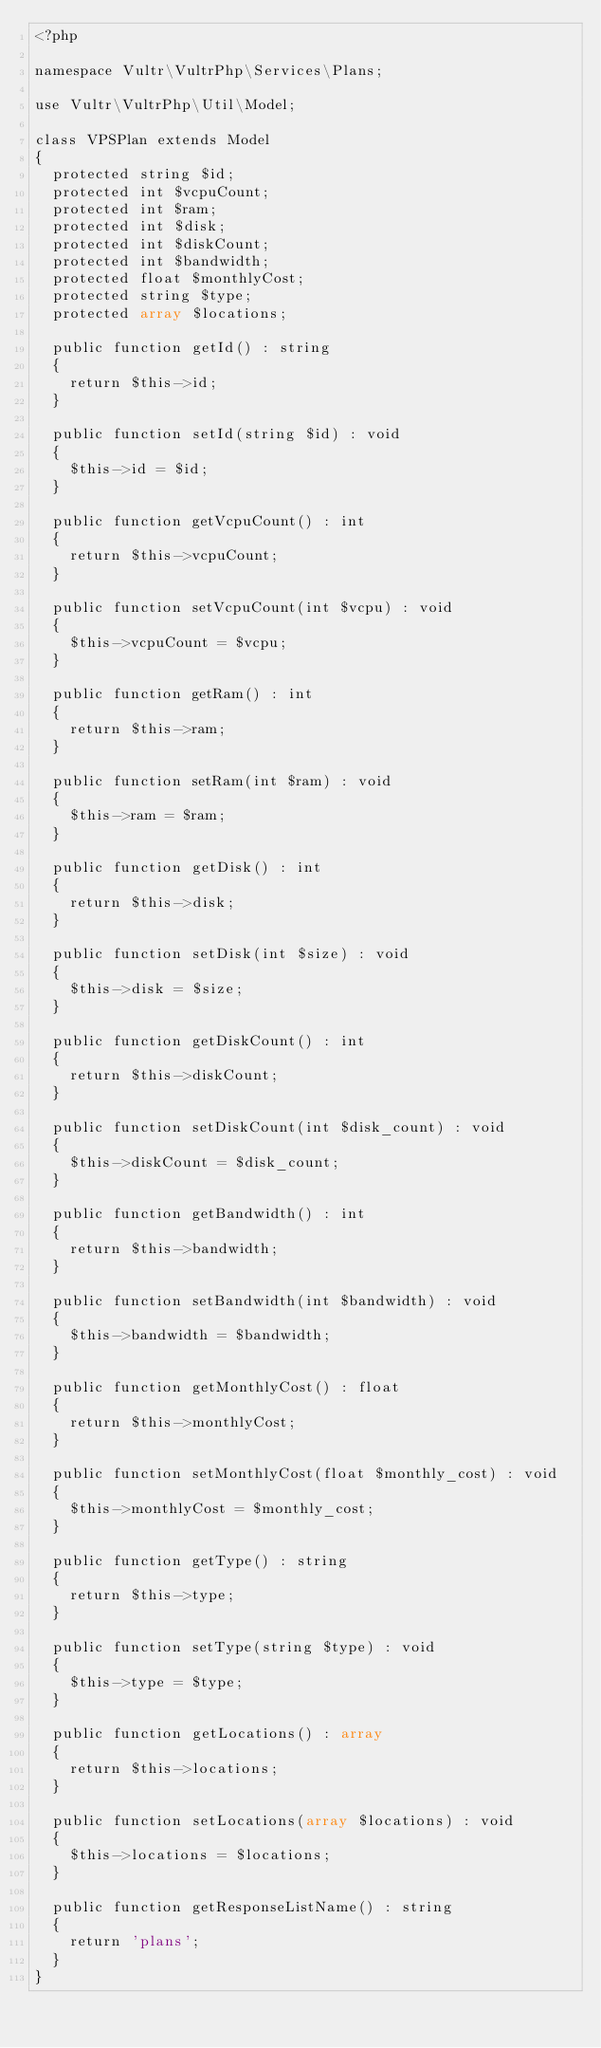<code> <loc_0><loc_0><loc_500><loc_500><_PHP_><?php

namespace Vultr\VultrPhp\Services\Plans;

use Vultr\VultrPhp\Util\Model;

class VPSPlan extends Model
{
	protected string $id;
	protected int $vcpuCount;
	protected int $ram;
	protected int $disk;
	protected int $diskCount;
	protected int $bandwidth;
	protected float $monthlyCost;
	protected string $type;
	protected array $locations;

	public function getId() : string
	{
		return $this->id;
	}

	public function setId(string $id) : void
	{
		$this->id = $id;
	}

	public function getVcpuCount() : int
	{
		return $this->vcpuCount;
	}

	public function setVcpuCount(int $vcpu) : void
	{
		$this->vcpuCount = $vcpu;
	}

	public function getRam() : int
	{
		return $this->ram;
	}

	public function setRam(int $ram) : void
	{
		$this->ram = $ram;
	}

	public function getDisk() : int
	{
		return $this->disk;
	}

	public function setDisk(int $size) : void
	{
		$this->disk = $size;
	}

	public function getDiskCount() : int
	{
		return $this->diskCount;
	}

	public function setDiskCount(int $disk_count) : void
	{
		$this->diskCount = $disk_count;
	}

	public function getBandwidth() : int
	{
		return $this->bandwidth;
	}

	public function setBandwidth(int $bandwidth) : void
	{
		$this->bandwidth = $bandwidth;
	}

	public function getMonthlyCost() : float
	{
		return $this->monthlyCost;
	}

	public function setMonthlyCost(float $monthly_cost) : void
	{
		$this->monthlyCost = $monthly_cost;
	}

	public function getType() : string
	{
		return $this->type;
	}

	public function setType(string $type) : void
	{
		$this->type = $type;
	}

	public function getLocations() : array
	{
		return $this->locations;
	}

	public function setLocations(array $locations) : void
	{
		$this->locations = $locations;
	}

	public function getResponseListName() : string
	{
		return 'plans';
	}
}
</code> 